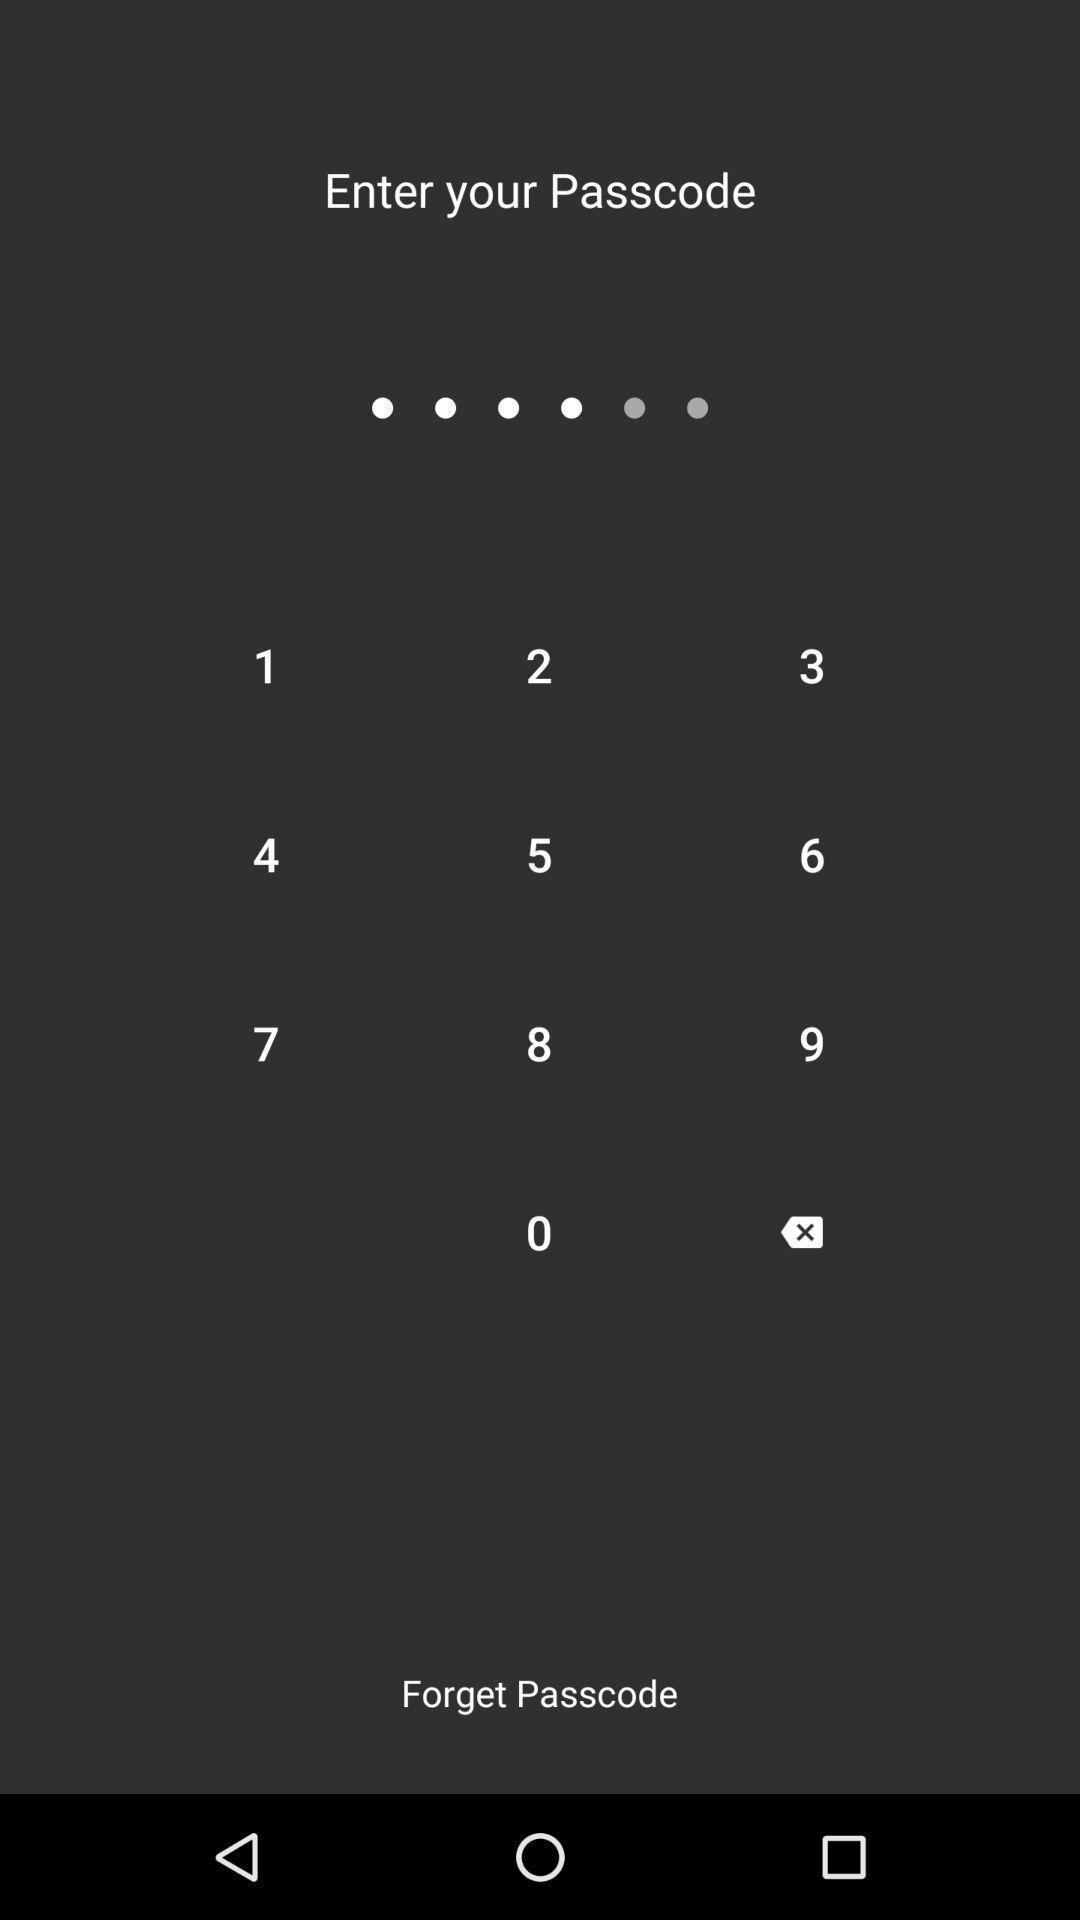Describe the key features of this screenshot. Page requesting to enter passcode on an app. 